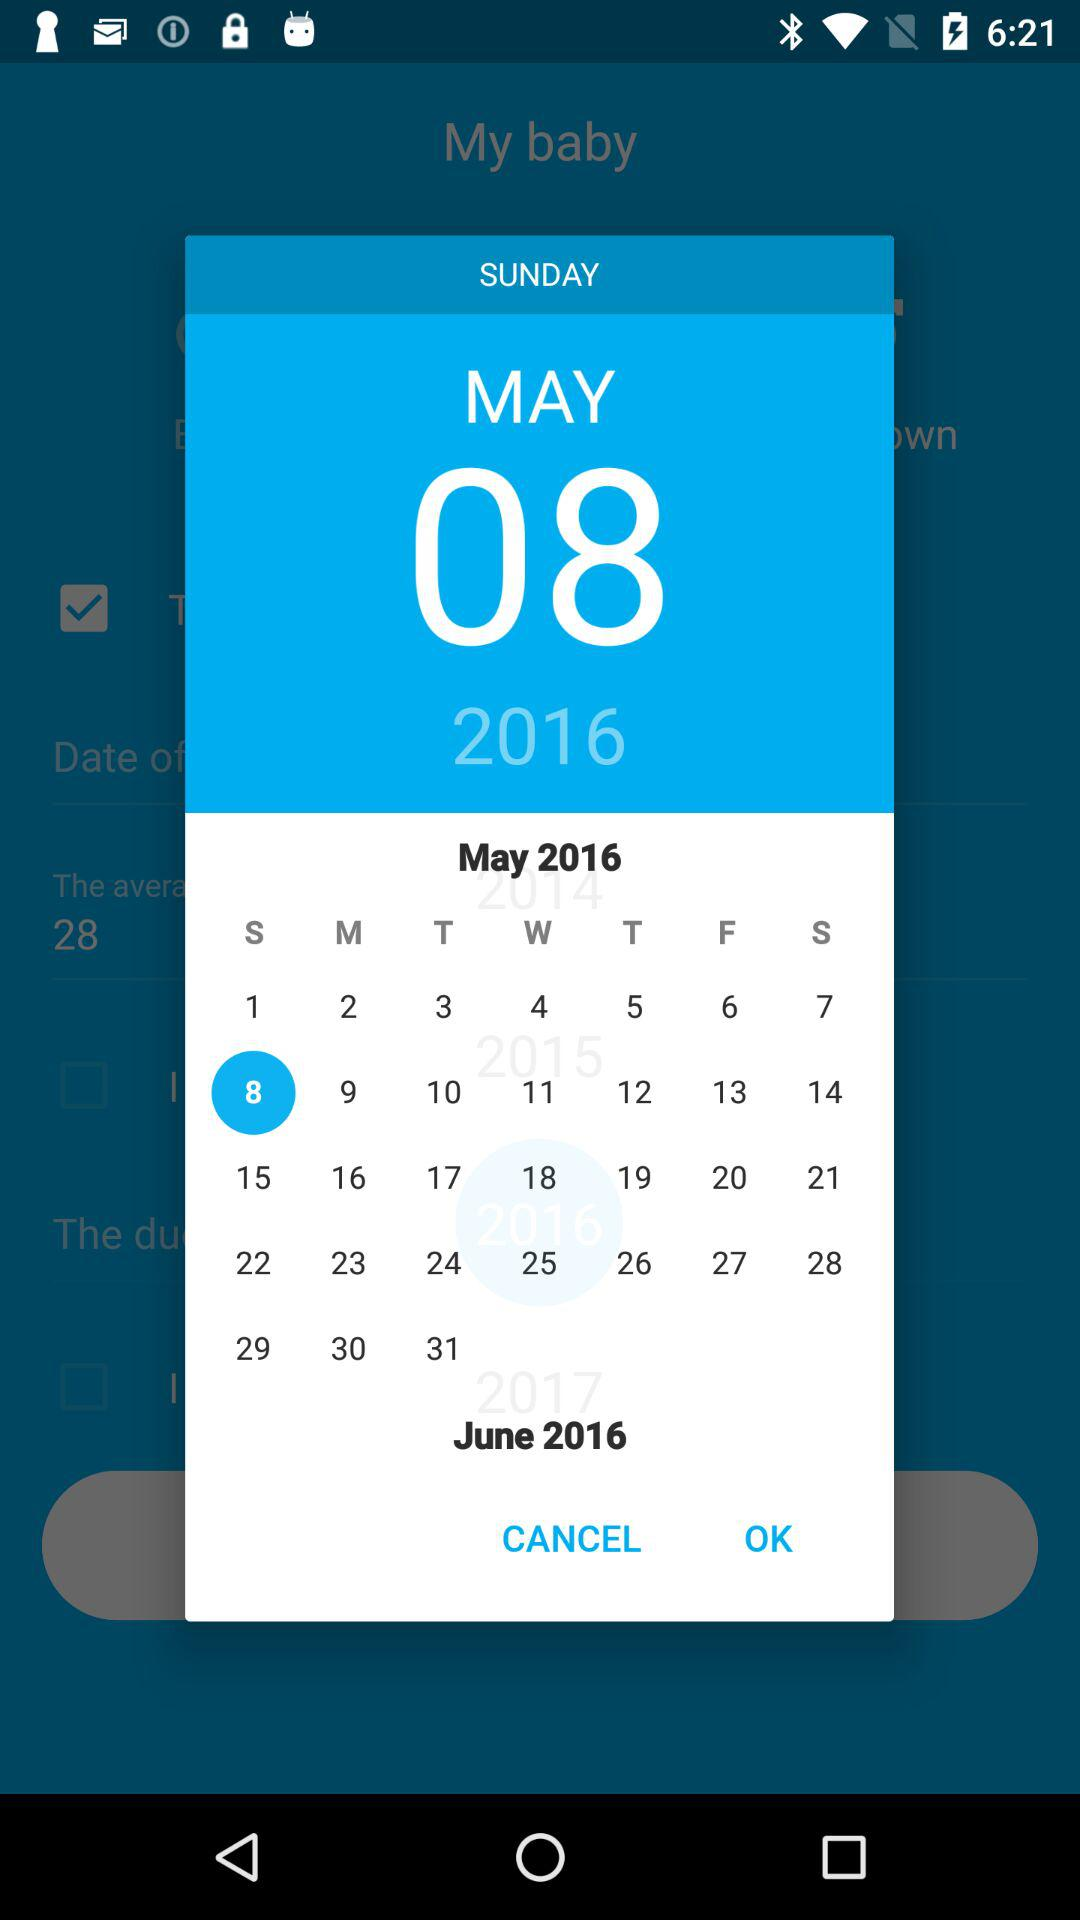What is the day? The day is Sunday. 